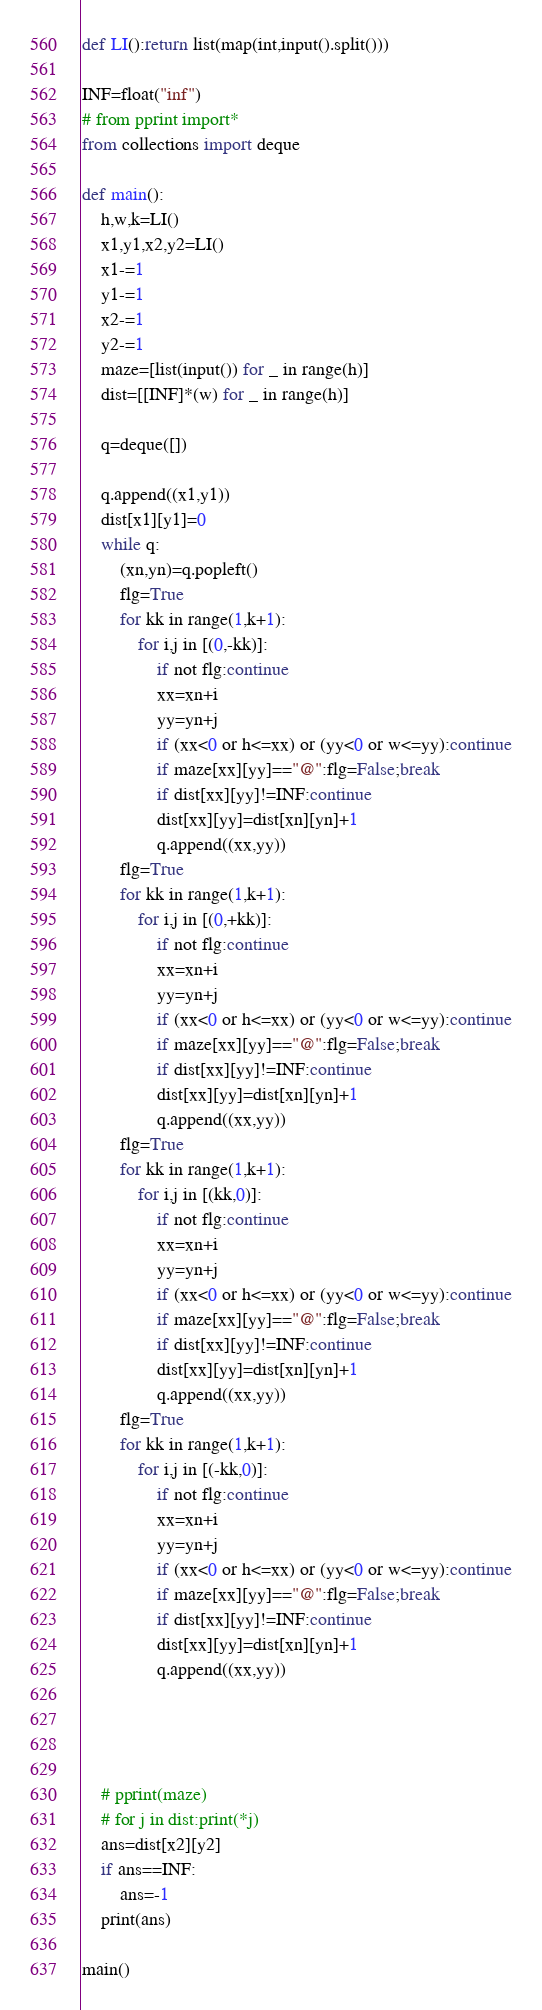<code> <loc_0><loc_0><loc_500><loc_500><_Python_>def LI():return list(map(int,input().split()))

INF=float("inf")
# from pprint import*
from collections import deque

def main():
    h,w,k=LI()
    x1,y1,x2,y2=LI()
    x1-=1
    y1-=1
    x2-=1
    y2-=1
    maze=[list(input()) for _ in range(h)]
    dist=[[INF]*(w) for _ in range(h)]
    
    q=deque([])
    
    q.append((x1,y1))
    dist[x1][y1]=0
    while q:
        (xn,yn)=q.popleft()
        flg=True
        for kk in range(1,k+1):
            for i,j in [(0,-kk)]:
                if not flg:continue
                xx=xn+i
                yy=yn+j
                if (xx<0 or h<=xx) or (yy<0 or w<=yy):continue
                if maze[xx][yy]=="@":flg=False;break
                if dist[xx][yy]!=INF:continue
                dist[xx][yy]=dist[xn][yn]+1
                q.append((xx,yy))
        flg=True
        for kk in range(1,k+1):
            for i,j in [(0,+kk)]:
                if not flg:continue
                xx=xn+i
                yy=yn+j
                if (xx<0 or h<=xx) or (yy<0 or w<=yy):continue
                if maze[xx][yy]=="@":flg=False;break
                if dist[xx][yy]!=INF:continue
                dist[xx][yy]=dist[xn][yn]+1
                q.append((xx,yy))
        flg=True
        for kk in range(1,k+1):
            for i,j in [(kk,0)]:
                if not flg:continue
                xx=xn+i
                yy=yn+j
                if (xx<0 or h<=xx) or (yy<0 or w<=yy):continue
                if maze[xx][yy]=="@":flg=False;break
                if dist[xx][yy]!=INF:continue
                dist[xx][yy]=dist[xn][yn]+1
                q.append((xx,yy))
        flg=True
        for kk in range(1,k+1):
            for i,j in [(-kk,0)]:
                if not flg:continue
                xx=xn+i
                yy=yn+j
                if (xx<0 or h<=xx) or (yy<0 or w<=yy):continue
                if maze[xx][yy]=="@":flg=False;break
                if dist[xx][yy]!=INF:continue
                dist[xx][yy]=dist[xn][yn]+1
                q.append((xx,yy))
        
        
        
        
    # pprint(maze)
    # for j in dist:print(*j)
    ans=dist[x2][y2]
    if ans==INF:
        ans=-1
    print(ans)  
    
main()</code> 